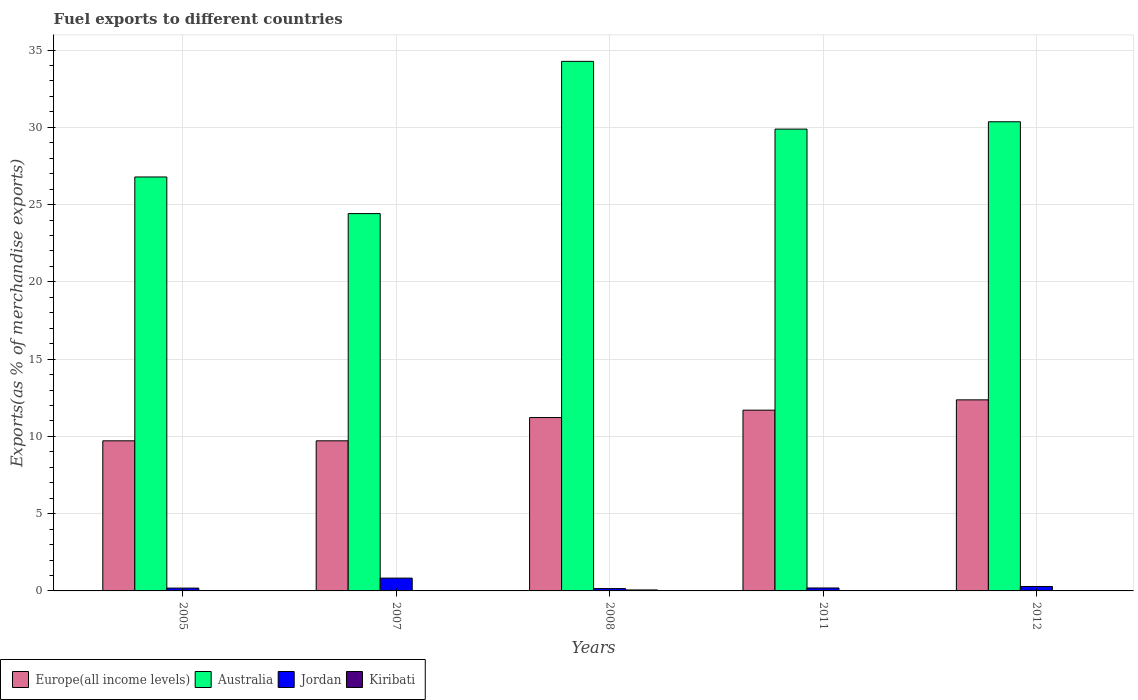How many different coloured bars are there?
Keep it short and to the point. 4. How many groups of bars are there?
Ensure brevity in your answer.  5. Are the number of bars per tick equal to the number of legend labels?
Provide a short and direct response. Yes. How many bars are there on the 2nd tick from the left?
Offer a terse response. 4. In how many cases, is the number of bars for a given year not equal to the number of legend labels?
Provide a short and direct response. 0. What is the percentage of exports to different countries in Europe(all income levels) in 2005?
Your answer should be compact. 9.71. Across all years, what is the maximum percentage of exports to different countries in Australia?
Offer a very short reply. 34.27. Across all years, what is the minimum percentage of exports to different countries in Australia?
Your answer should be very brief. 24.42. In which year was the percentage of exports to different countries in Australia maximum?
Your response must be concise. 2008. What is the total percentage of exports to different countries in Europe(all income levels) in the graph?
Ensure brevity in your answer.  54.7. What is the difference between the percentage of exports to different countries in Europe(all income levels) in 2005 and that in 2012?
Make the answer very short. -2.65. What is the difference between the percentage of exports to different countries in Australia in 2005 and the percentage of exports to different countries in Europe(all income levels) in 2012?
Your response must be concise. 14.42. What is the average percentage of exports to different countries in Kiribati per year?
Offer a terse response. 0.02. In the year 2007, what is the difference between the percentage of exports to different countries in Australia and percentage of exports to different countries in Kiribati?
Offer a very short reply. 24.42. What is the ratio of the percentage of exports to different countries in Europe(all income levels) in 2005 to that in 2008?
Offer a terse response. 0.87. Is the difference between the percentage of exports to different countries in Australia in 2005 and 2011 greater than the difference between the percentage of exports to different countries in Kiribati in 2005 and 2011?
Make the answer very short. No. What is the difference between the highest and the second highest percentage of exports to different countries in Kiribati?
Offer a very short reply. 0.05. What is the difference between the highest and the lowest percentage of exports to different countries in Australia?
Offer a terse response. 9.85. In how many years, is the percentage of exports to different countries in Australia greater than the average percentage of exports to different countries in Australia taken over all years?
Ensure brevity in your answer.  3. Is it the case that in every year, the sum of the percentage of exports to different countries in Jordan and percentage of exports to different countries in Europe(all income levels) is greater than the sum of percentage of exports to different countries in Kiribati and percentage of exports to different countries in Australia?
Offer a terse response. Yes. What does the 1st bar from the right in 2012 represents?
Provide a succinct answer. Kiribati. Is it the case that in every year, the sum of the percentage of exports to different countries in Europe(all income levels) and percentage of exports to different countries in Australia is greater than the percentage of exports to different countries in Jordan?
Keep it short and to the point. Yes. How many bars are there?
Offer a very short reply. 20. Are all the bars in the graph horizontal?
Make the answer very short. No. How many years are there in the graph?
Give a very brief answer. 5. What is the difference between two consecutive major ticks on the Y-axis?
Make the answer very short. 5. Are the values on the major ticks of Y-axis written in scientific E-notation?
Offer a very short reply. No. Does the graph contain any zero values?
Offer a very short reply. No. Does the graph contain grids?
Provide a succinct answer. Yes. How are the legend labels stacked?
Your answer should be compact. Horizontal. What is the title of the graph?
Ensure brevity in your answer.  Fuel exports to different countries. What is the label or title of the Y-axis?
Keep it short and to the point. Exports(as % of merchandise exports). What is the Exports(as % of merchandise exports) in Europe(all income levels) in 2005?
Your answer should be compact. 9.71. What is the Exports(as % of merchandise exports) of Australia in 2005?
Ensure brevity in your answer.  26.79. What is the Exports(as % of merchandise exports) of Jordan in 2005?
Provide a succinct answer. 0.18. What is the Exports(as % of merchandise exports) in Kiribati in 2005?
Provide a short and direct response. 0.02. What is the Exports(as % of merchandise exports) of Europe(all income levels) in 2007?
Make the answer very short. 9.71. What is the Exports(as % of merchandise exports) of Australia in 2007?
Provide a succinct answer. 24.42. What is the Exports(as % of merchandise exports) in Jordan in 2007?
Keep it short and to the point. 0.83. What is the Exports(as % of merchandise exports) in Kiribati in 2007?
Provide a short and direct response. 0. What is the Exports(as % of merchandise exports) in Europe(all income levels) in 2008?
Your response must be concise. 11.22. What is the Exports(as % of merchandise exports) of Australia in 2008?
Your response must be concise. 34.27. What is the Exports(as % of merchandise exports) of Jordan in 2008?
Provide a short and direct response. 0.15. What is the Exports(as % of merchandise exports) in Kiribati in 2008?
Keep it short and to the point. 0.06. What is the Exports(as % of merchandise exports) in Europe(all income levels) in 2011?
Offer a very short reply. 11.7. What is the Exports(as % of merchandise exports) of Australia in 2011?
Your answer should be compact. 29.88. What is the Exports(as % of merchandise exports) of Jordan in 2011?
Make the answer very short. 0.19. What is the Exports(as % of merchandise exports) of Kiribati in 2011?
Offer a terse response. 0. What is the Exports(as % of merchandise exports) in Europe(all income levels) in 2012?
Provide a succinct answer. 12.36. What is the Exports(as % of merchandise exports) of Australia in 2012?
Ensure brevity in your answer.  30.36. What is the Exports(as % of merchandise exports) in Jordan in 2012?
Make the answer very short. 0.29. What is the Exports(as % of merchandise exports) in Kiribati in 2012?
Ensure brevity in your answer.  0. Across all years, what is the maximum Exports(as % of merchandise exports) in Europe(all income levels)?
Ensure brevity in your answer.  12.36. Across all years, what is the maximum Exports(as % of merchandise exports) of Australia?
Your response must be concise. 34.27. Across all years, what is the maximum Exports(as % of merchandise exports) in Jordan?
Provide a short and direct response. 0.83. Across all years, what is the maximum Exports(as % of merchandise exports) of Kiribati?
Your response must be concise. 0.06. Across all years, what is the minimum Exports(as % of merchandise exports) in Europe(all income levels)?
Give a very brief answer. 9.71. Across all years, what is the minimum Exports(as % of merchandise exports) in Australia?
Offer a very short reply. 24.42. Across all years, what is the minimum Exports(as % of merchandise exports) of Jordan?
Make the answer very short. 0.15. Across all years, what is the minimum Exports(as % of merchandise exports) in Kiribati?
Offer a terse response. 0. What is the total Exports(as % of merchandise exports) of Europe(all income levels) in the graph?
Ensure brevity in your answer.  54.7. What is the total Exports(as % of merchandise exports) in Australia in the graph?
Give a very brief answer. 145.71. What is the total Exports(as % of merchandise exports) of Jordan in the graph?
Your answer should be compact. 1.64. What is the total Exports(as % of merchandise exports) of Kiribati in the graph?
Provide a short and direct response. 0.08. What is the difference between the Exports(as % of merchandise exports) of Europe(all income levels) in 2005 and that in 2007?
Your answer should be very brief. -0. What is the difference between the Exports(as % of merchandise exports) in Australia in 2005 and that in 2007?
Make the answer very short. 2.37. What is the difference between the Exports(as % of merchandise exports) in Jordan in 2005 and that in 2007?
Your answer should be very brief. -0.65. What is the difference between the Exports(as % of merchandise exports) in Kiribati in 2005 and that in 2007?
Your answer should be very brief. 0.02. What is the difference between the Exports(as % of merchandise exports) of Europe(all income levels) in 2005 and that in 2008?
Offer a terse response. -1.51. What is the difference between the Exports(as % of merchandise exports) in Australia in 2005 and that in 2008?
Give a very brief answer. -7.48. What is the difference between the Exports(as % of merchandise exports) in Jordan in 2005 and that in 2008?
Your response must be concise. 0.03. What is the difference between the Exports(as % of merchandise exports) of Kiribati in 2005 and that in 2008?
Give a very brief answer. -0.05. What is the difference between the Exports(as % of merchandise exports) of Europe(all income levels) in 2005 and that in 2011?
Your answer should be very brief. -1.98. What is the difference between the Exports(as % of merchandise exports) of Australia in 2005 and that in 2011?
Keep it short and to the point. -3.1. What is the difference between the Exports(as % of merchandise exports) of Jordan in 2005 and that in 2011?
Give a very brief answer. -0.01. What is the difference between the Exports(as % of merchandise exports) in Kiribati in 2005 and that in 2011?
Ensure brevity in your answer.  0.02. What is the difference between the Exports(as % of merchandise exports) of Europe(all income levels) in 2005 and that in 2012?
Provide a short and direct response. -2.65. What is the difference between the Exports(as % of merchandise exports) of Australia in 2005 and that in 2012?
Provide a succinct answer. -3.57. What is the difference between the Exports(as % of merchandise exports) in Jordan in 2005 and that in 2012?
Offer a very short reply. -0.11. What is the difference between the Exports(as % of merchandise exports) in Kiribati in 2005 and that in 2012?
Give a very brief answer. 0.02. What is the difference between the Exports(as % of merchandise exports) of Europe(all income levels) in 2007 and that in 2008?
Give a very brief answer. -1.51. What is the difference between the Exports(as % of merchandise exports) in Australia in 2007 and that in 2008?
Offer a very short reply. -9.85. What is the difference between the Exports(as % of merchandise exports) in Jordan in 2007 and that in 2008?
Your response must be concise. 0.68. What is the difference between the Exports(as % of merchandise exports) in Kiribati in 2007 and that in 2008?
Ensure brevity in your answer.  -0.06. What is the difference between the Exports(as % of merchandise exports) in Europe(all income levels) in 2007 and that in 2011?
Give a very brief answer. -1.98. What is the difference between the Exports(as % of merchandise exports) of Australia in 2007 and that in 2011?
Ensure brevity in your answer.  -5.47. What is the difference between the Exports(as % of merchandise exports) in Jordan in 2007 and that in 2011?
Make the answer very short. 0.64. What is the difference between the Exports(as % of merchandise exports) in Kiribati in 2007 and that in 2011?
Offer a very short reply. 0. What is the difference between the Exports(as % of merchandise exports) of Europe(all income levels) in 2007 and that in 2012?
Provide a succinct answer. -2.65. What is the difference between the Exports(as % of merchandise exports) in Australia in 2007 and that in 2012?
Give a very brief answer. -5.94. What is the difference between the Exports(as % of merchandise exports) in Jordan in 2007 and that in 2012?
Your answer should be compact. 0.54. What is the difference between the Exports(as % of merchandise exports) in Europe(all income levels) in 2008 and that in 2011?
Your answer should be compact. -0.48. What is the difference between the Exports(as % of merchandise exports) in Australia in 2008 and that in 2011?
Offer a terse response. 4.38. What is the difference between the Exports(as % of merchandise exports) in Jordan in 2008 and that in 2011?
Provide a succinct answer. -0.04. What is the difference between the Exports(as % of merchandise exports) of Kiribati in 2008 and that in 2011?
Your answer should be very brief. 0.06. What is the difference between the Exports(as % of merchandise exports) in Europe(all income levels) in 2008 and that in 2012?
Give a very brief answer. -1.15. What is the difference between the Exports(as % of merchandise exports) of Australia in 2008 and that in 2012?
Give a very brief answer. 3.91. What is the difference between the Exports(as % of merchandise exports) in Jordan in 2008 and that in 2012?
Offer a terse response. -0.14. What is the difference between the Exports(as % of merchandise exports) of Kiribati in 2008 and that in 2012?
Ensure brevity in your answer.  0.06. What is the difference between the Exports(as % of merchandise exports) in Europe(all income levels) in 2011 and that in 2012?
Provide a short and direct response. -0.67. What is the difference between the Exports(as % of merchandise exports) in Australia in 2011 and that in 2012?
Keep it short and to the point. -0.47. What is the difference between the Exports(as % of merchandise exports) of Jordan in 2011 and that in 2012?
Keep it short and to the point. -0.1. What is the difference between the Exports(as % of merchandise exports) in Kiribati in 2011 and that in 2012?
Provide a succinct answer. -0. What is the difference between the Exports(as % of merchandise exports) in Europe(all income levels) in 2005 and the Exports(as % of merchandise exports) in Australia in 2007?
Offer a terse response. -14.7. What is the difference between the Exports(as % of merchandise exports) of Europe(all income levels) in 2005 and the Exports(as % of merchandise exports) of Jordan in 2007?
Ensure brevity in your answer.  8.88. What is the difference between the Exports(as % of merchandise exports) of Europe(all income levels) in 2005 and the Exports(as % of merchandise exports) of Kiribati in 2007?
Ensure brevity in your answer.  9.71. What is the difference between the Exports(as % of merchandise exports) in Australia in 2005 and the Exports(as % of merchandise exports) in Jordan in 2007?
Offer a very short reply. 25.96. What is the difference between the Exports(as % of merchandise exports) in Australia in 2005 and the Exports(as % of merchandise exports) in Kiribati in 2007?
Provide a short and direct response. 26.79. What is the difference between the Exports(as % of merchandise exports) in Jordan in 2005 and the Exports(as % of merchandise exports) in Kiribati in 2007?
Keep it short and to the point. 0.18. What is the difference between the Exports(as % of merchandise exports) of Europe(all income levels) in 2005 and the Exports(as % of merchandise exports) of Australia in 2008?
Give a very brief answer. -24.55. What is the difference between the Exports(as % of merchandise exports) of Europe(all income levels) in 2005 and the Exports(as % of merchandise exports) of Jordan in 2008?
Provide a short and direct response. 9.56. What is the difference between the Exports(as % of merchandise exports) in Europe(all income levels) in 2005 and the Exports(as % of merchandise exports) in Kiribati in 2008?
Give a very brief answer. 9.65. What is the difference between the Exports(as % of merchandise exports) of Australia in 2005 and the Exports(as % of merchandise exports) of Jordan in 2008?
Ensure brevity in your answer.  26.63. What is the difference between the Exports(as % of merchandise exports) in Australia in 2005 and the Exports(as % of merchandise exports) in Kiribati in 2008?
Make the answer very short. 26.72. What is the difference between the Exports(as % of merchandise exports) in Jordan in 2005 and the Exports(as % of merchandise exports) in Kiribati in 2008?
Offer a terse response. 0.12. What is the difference between the Exports(as % of merchandise exports) of Europe(all income levels) in 2005 and the Exports(as % of merchandise exports) of Australia in 2011?
Provide a succinct answer. -20.17. What is the difference between the Exports(as % of merchandise exports) of Europe(all income levels) in 2005 and the Exports(as % of merchandise exports) of Jordan in 2011?
Provide a short and direct response. 9.52. What is the difference between the Exports(as % of merchandise exports) in Europe(all income levels) in 2005 and the Exports(as % of merchandise exports) in Kiribati in 2011?
Provide a short and direct response. 9.71. What is the difference between the Exports(as % of merchandise exports) in Australia in 2005 and the Exports(as % of merchandise exports) in Jordan in 2011?
Your answer should be very brief. 26.6. What is the difference between the Exports(as % of merchandise exports) in Australia in 2005 and the Exports(as % of merchandise exports) in Kiribati in 2011?
Provide a succinct answer. 26.79. What is the difference between the Exports(as % of merchandise exports) of Jordan in 2005 and the Exports(as % of merchandise exports) of Kiribati in 2011?
Offer a very short reply. 0.18. What is the difference between the Exports(as % of merchandise exports) of Europe(all income levels) in 2005 and the Exports(as % of merchandise exports) of Australia in 2012?
Offer a very short reply. -20.64. What is the difference between the Exports(as % of merchandise exports) of Europe(all income levels) in 2005 and the Exports(as % of merchandise exports) of Jordan in 2012?
Your answer should be very brief. 9.42. What is the difference between the Exports(as % of merchandise exports) of Europe(all income levels) in 2005 and the Exports(as % of merchandise exports) of Kiribati in 2012?
Provide a short and direct response. 9.71. What is the difference between the Exports(as % of merchandise exports) of Australia in 2005 and the Exports(as % of merchandise exports) of Jordan in 2012?
Your response must be concise. 26.5. What is the difference between the Exports(as % of merchandise exports) in Australia in 2005 and the Exports(as % of merchandise exports) in Kiribati in 2012?
Your answer should be very brief. 26.79. What is the difference between the Exports(as % of merchandise exports) in Jordan in 2005 and the Exports(as % of merchandise exports) in Kiribati in 2012?
Your answer should be very brief. 0.18. What is the difference between the Exports(as % of merchandise exports) in Europe(all income levels) in 2007 and the Exports(as % of merchandise exports) in Australia in 2008?
Provide a short and direct response. -24.55. What is the difference between the Exports(as % of merchandise exports) in Europe(all income levels) in 2007 and the Exports(as % of merchandise exports) in Jordan in 2008?
Provide a succinct answer. 9.56. What is the difference between the Exports(as % of merchandise exports) of Europe(all income levels) in 2007 and the Exports(as % of merchandise exports) of Kiribati in 2008?
Your answer should be compact. 9.65. What is the difference between the Exports(as % of merchandise exports) of Australia in 2007 and the Exports(as % of merchandise exports) of Jordan in 2008?
Make the answer very short. 24.27. What is the difference between the Exports(as % of merchandise exports) of Australia in 2007 and the Exports(as % of merchandise exports) of Kiribati in 2008?
Provide a short and direct response. 24.35. What is the difference between the Exports(as % of merchandise exports) in Jordan in 2007 and the Exports(as % of merchandise exports) in Kiribati in 2008?
Make the answer very short. 0.77. What is the difference between the Exports(as % of merchandise exports) in Europe(all income levels) in 2007 and the Exports(as % of merchandise exports) in Australia in 2011?
Your answer should be very brief. -20.17. What is the difference between the Exports(as % of merchandise exports) of Europe(all income levels) in 2007 and the Exports(as % of merchandise exports) of Jordan in 2011?
Provide a short and direct response. 9.52. What is the difference between the Exports(as % of merchandise exports) in Europe(all income levels) in 2007 and the Exports(as % of merchandise exports) in Kiribati in 2011?
Your response must be concise. 9.71. What is the difference between the Exports(as % of merchandise exports) in Australia in 2007 and the Exports(as % of merchandise exports) in Jordan in 2011?
Ensure brevity in your answer.  24.23. What is the difference between the Exports(as % of merchandise exports) of Australia in 2007 and the Exports(as % of merchandise exports) of Kiribati in 2011?
Provide a short and direct response. 24.42. What is the difference between the Exports(as % of merchandise exports) of Jordan in 2007 and the Exports(as % of merchandise exports) of Kiribati in 2011?
Your answer should be very brief. 0.83. What is the difference between the Exports(as % of merchandise exports) in Europe(all income levels) in 2007 and the Exports(as % of merchandise exports) in Australia in 2012?
Your answer should be compact. -20.64. What is the difference between the Exports(as % of merchandise exports) of Europe(all income levels) in 2007 and the Exports(as % of merchandise exports) of Jordan in 2012?
Offer a very short reply. 9.42. What is the difference between the Exports(as % of merchandise exports) in Europe(all income levels) in 2007 and the Exports(as % of merchandise exports) in Kiribati in 2012?
Give a very brief answer. 9.71. What is the difference between the Exports(as % of merchandise exports) in Australia in 2007 and the Exports(as % of merchandise exports) in Jordan in 2012?
Offer a very short reply. 24.13. What is the difference between the Exports(as % of merchandise exports) of Australia in 2007 and the Exports(as % of merchandise exports) of Kiribati in 2012?
Your response must be concise. 24.42. What is the difference between the Exports(as % of merchandise exports) in Jordan in 2007 and the Exports(as % of merchandise exports) in Kiribati in 2012?
Give a very brief answer. 0.83. What is the difference between the Exports(as % of merchandise exports) of Europe(all income levels) in 2008 and the Exports(as % of merchandise exports) of Australia in 2011?
Keep it short and to the point. -18.66. What is the difference between the Exports(as % of merchandise exports) in Europe(all income levels) in 2008 and the Exports(as % of merchandise exports) in Jordan in 2011?
Your answer should be very brief. 11.03. What is the difference between the Exports(as % of merchandise exports) in Europe(all income levels) in 2008 and the Exports(as % of merchandise exports) in Kiribati in 2011?
Your answer should be compact. 11.22. What is the difference between the Exports(as % of merchandise exports) in Australia in 2008 and the Exports(as % of merchandise exports) in Jordan in 2011?
Ensure brevity in your answer.  34.08. What is the difference between the Exports(as % of merchandise exports) of Australia in 2008 and the Exports(as % of merchandise exports) of Kiribati in 2011?
Provide a short and direct response. 34.27. What is the difference between the Exports(as % of merchandise exports) of Jordan in 2008 and the Exports(as % of merchandise exports) of Kiribati in 2011?
Your answer should be compact. 0.15. What is the difference between the Exports(as % of merchandise exports) of Europe(all income levels) in 2008 and the Exports(as % of merchandise exports) of Australia in 2012?
Keep it short and to the point. -19.14. What is the difference between the Exports(as % of merchandise exports) in Europe(all income levels) in 2008 and the Exports(as % of merchandise exports) in Jordan in 2012?
Make the answer very short. 10.93. What is the difference between the Exports(as % of merchandise exports) in Europe(all income levels) in 2008 and the Exports(as % of merchandise exports) in Kiribati in 2012?
Ensure brevity in your answer.  11.22. What is the difference between the Exports(as % of merchandise exports) in Australia in 2008 and the Exports(as % of merchandise exports) in Jordan in 2012?
Offer a terse response. 33.98. What is the difference between the Exports(as % of merchandise exports) of Australia in 2008 and the Exports(as % of merchandise exports) of Kiribati in 2012?
Your response must be concise. 34.27. What is the difference between the Exports(as % of merchandise exports) of Jordan in 2008 and the Exports(as % of merchandise exports) of Kiribati in 2012?
Provide a short and direct response. 0.15. What is the difference between the Exports(as % of merchandise exports) of Europe(all income levels) in 2011 and the Exports(as % of merchandise exports) of Australia in 2012?
Your answer should be very brief. -18.66. What is the difference between the Exports(as % of merchandise exports) of Europe(all income levels) in 2011 and the Exports(as % of merchandise exports) of Jordan in 2012?
Give a very brief answer. 11.41. What is the difference between the Exports(as % of merchandise exports) of Europe(all income levels) in 2011 and the Exports(as % of merchandise exports) of Kiribati in 2012?
Offer a terse response. 11.7. What is the difference between the Exports(as % of merchandise exports) of Australia in 2011 and the Exports(as % of merchandise exports) of Jordan in 2012?
Offer a very short reply. 29.6. What is the difference between the Exports(as % of merchandise exports) of Australia in 2011 and the Exports(as % of merchandise exports) of Kiribati in 2012?
Your answer should be very brief. 29.88. What is the difference between the Exports(as % of merchandise exports) of Jordan in 2011 and the Exports(as % of merchandise exports) of Kiribati in 2012?
Keep it short and to the point. 0.19. What is the average Exports(as % of merchandise exports) of Europe(all income levels) per year?
Your answer should be compact. 10.94. What is the average Exports(as % of merchandise exports) in Australia per year?
Give a very brief answer. 29.14. What is the average Exports(as % of merchandise exports) in Jordan per year?
Ensure brevity in your answer.  0.33. What is the average Exports(as % of merchandise exports) of Kiribati per year?
Your answer should be very brief. 0.02. In the year 2005, what is the difference between the Exports(as % of merchandise exports) in Europe(all income levels) and Exports(as % of merchandise exports) in Australia?
Provide a succinct answer. -17.07. In the year 2005, what is the difference between the Exports(as % of merchandise exports) in Europe(all income levels) and Exports(as % of merchandise exports) in Jordan?
Make the answer very short. 9.53. In the year 2005, what is the difference between the Exports(as % of merchandise exports) of Europe(all income levels) and Exports(as % of merchandise exports) of Kiribati?
Provide a short and direct response. 9.7. In the year 2005, what is the difference between the Exports(as % of merchandise exports) in Australia and Exports(as % of merchandise exports) in Jordan?
Your answer should be very brief. 26.6. In the year 2005, what is the difference between the Exports(as % of merchandise exports) in Australia and Exports(as % of merchandise exports) in Kiribati?
Ensure brevity in your answer.  26.77. In the year 2005, what is the difference between the Exports(as % of merchandise exports) in Jordan and Exports(as % of merchandise exports) in Kiribati?
Keep it short and to the point. 0.17. In the year 2007, what is the difference between the Exports(as % of merchandise exports) of Europe(all income levels) and Exports(as % of merchandise exports) of Australia?
Keep it short and to the point. -14.7. In the year 2007, what is the difference between the Exports(as % of merchandise exports) in Europe(all income levels) and Exports(as % of merchandise exports) in Jordan?
Make the answer very short. 8.88. In the year 2007, what is the difference between the Exports(as % of merchandise exports) in Europe(all income levels) and Exports(as % of merchandise exports) in Kiribati?
Make the answer very short. 9.71. In the year 2007, what is the difference between the Exports(as % of merchandise exports) of Australia and Exports(as % of merchandise exports) of Jordan?
Make the answer very short. 23.59. In the year 2007, what is the difference between the Exports(as % of merchandise exports) in Australia and Exports(as % of merchandise exports) in Kiribati?
Your response must be concise. 24.42. In the year 2007, what is the difference between the Exports(as % of merchandise exports) of Jordan and Exports(as % of merchandise exports) of Kiribati?
Keep it short and to the point. 0.83. In the year 2008, what is the difference between the Exports(as % of merchandise exports) in Europe(all income levels) and Exports(as % of merchandise exports) in Australia?
Provide a short and direct response. -23.05. In the year 2008, what is the difference between the Exports(as % of merchandise exports) of Europe(all income levels) and Exports(as % of merchandise exports) of Jordan?
Ensure brevity in your answer.  11.07. In the year 2008, what is the difference between the Exports(as % of merchandise exports) of Europe(all income levels) and Exports(as % of merchandise exports) of Kiribati?
Your response must be concise. 11.16. In the year 2008, what is the difference between the Exports(as % of merchandise exports) of Australia and Exports(as % of merchandise exports) of Jordan?
Your answer should be compact. 34.12. In the year 2008, what is the difference between the Exports(as % of merchandise exports) in Australia and Exports(as % of merchandise exports) in Kiribati?
Provide a succinct answer. 34.2. In the year 2008, what is the difference between the Exports(as % of merchandise exports) in Jordan and Exports(as % of merchandise exports) in Kiribati?
Give a very brief answer. 0.09. In the year 2011, what is the difference between the Exports(as % of merchandise exports) of Europe(all income levels) and Exports(as % of merchandise exports) of Australia?
Give a very brief answer. -18.19. In the year 2011, what is the difference between the Exports(as % of merchandise exports) in Europe(all income levels) and Exports(as % of merchandise exports) in Jordan?
Offer a terse response. 11.51. In the year 2011, what is the difference between the Exports(as % of merchandise exports) in Europe(all income levels) and Exports(as % of merchandise exports) in Kiribati?
Keep it short and to the point. 11.7. In the year 2011, what is the difference between the Exports(as % of merchandise exports) in Australia and Exports(as % of merchandise exports) in Jordan?
Your answer should be very brief. 29.69. In the year 2011, what is the difference between the Exports(as % of merchandise exports) of Australia and Exports(as % of merchandise exports) of Kiribati?
Make the answer very short. 29.88. In the year 2011, what is the difference between the Exports(as % of merchandise exports) in Jordan and Exports(as % of merchandise exports) in Kiribati?
Ensure brevity in your answer.  0.19. In the year 2012, what is the difference between the Exports(as % of merchandise exports) in Europe(all income levels) and Exports(as % of merchandise exports) in Australia?
Offer a very short reply. -17.99. In the year 2012, what is the difference between the Exports(as % of merchandise exports) of Europe(all income levels) and Exports(as % of merchandise exports) of Jordan?
Make the answer very short. 12.08. In the year 2012, what is the difference between the Exports(as % of merchandise exports) in Europe(all income levels) and Exports(as % of merchandise exports) in Kiribati?
Offer a very short reply. 12.36. In the year 2012, what is the difference between the Exports(as % of merchandise exports) in Australia and Exports(as % of merchandise exports) in Jordan?
Offer a very short reply. 30.07. In the year 2012, what is the difference between the Exports(as % of merchandise exports) of Australia and Exports(as % of merchandise exports) of Kiribati?
Provide a short and direct response. 30.36. In the year 2012, what is the difference between the Exports(as % of merchandise exports) of Jordan and Exports(as % of merchandise exports) of Kiribati?
Ensure brevity in your answer.  0.29. What is the ratio of the Exports(as % of merchandise exports) of Australia in 2005 to that in 2007?
Your answer should be very brief. 1.1. What is the ratio of the Exports(as % of merchandise exports) in Jordan in 2005 to that in 2007?
Ensure brevity in your answer.  0.22. What is the ratio of the Exports(as % of merchandise exports) of Kiribati in 2005 to that in 2007?
Your response must be concise. 69.38. What is the ratio of the Exports(as % of merchandise exports) of Europe(all income levels) in 2005 to that in 2008?
Your answer should be very brief. 0.87. What is the ratio of the Exports(as % of merchandise exports) of Australia in 2005 to that in 2008?
Offer a very short reply. 0.78. What is the ratio of the Exports(as % of merchandise exports) in Jordan in 2005 to that in 2008?
Your response must be concise. 1.21. What is the ratio of the Exports(as % of merchandise exports) in Kiribati in 2005 to that in 2008?
Offer a very short reply. 0.27. What is the ratio of the Exports(as % of merchandise exports) in Europe(all income levels) in 2005 to that in 2011?
Your response must be concise. 0.83. What is the ratio of the Exports(as % of merchandise exports) in Australia in 2005 to that in 2011?
Offer a very short reply. 0.9. What is the ratio of the Exports(as % of merchandise exports) in Jordan in 2005 to that in 2011?
Ensure brevity in your answer.  0.96. What is the ratio of the Exports(as % of merchandise exports) of Kiribati in 2005 to that in 2011?
Make the answer very short. 147.01. What is the ratio of the Exports(as % of merchandise exports) in Europe(all income levels) in 2005 to that in 2012?
Keep it short and to the point. 0.79. What is the ratio of the Exports(as % of merchandise exports) in Australia in 2005 to that in 2012?
Provide a short and direct response. 0.88. What is the ratio of the Exports(as % of merchandise exports) in Jordan in 2005 to that in 2012?
Offer a terse response. 0.63. What is the ratio of the Exports(as % of merchandise exports) of Kiribati in 2005 to that in 2012?
Provide a succinct answer. 99.44. What is the ratio of the Exports(as % of merchandise exports) in Europe(all income levels) in 2007 to that in 2008?
Offer a terse response. 0.87. What is the ratio of the Exports(as % of merchandise exports) in Australia in 2007 to that in 2008?
Your answer should be very brief. 0.71. What is the ratio of the Exports(as % of merchandise exports) in Jordan in 2007 to that in 2008?
Your response must be concise. 5.5. What is the ratio of the Exports(as % of merchandise exports) in Kiribati in 2007 to that in 2008?
Make the answer very short. 0. What is the ratio of the Exports(as % of merchandise exports) of Europe(all income levels) in 2007 to that in 2011?
Keep it short and to the point. 0.83. What is the ratio of the Exports(as % of merchandise exports) of Australia in 2007 to that in 2011?
Your response must be concise. 0.82. What is the ratio of the Exports(as % of merchandise exports) in Jordan in 2007 to that in 2011?
Ensure brevity in your answer.  4.35. What is the ratio of the Exports(as % of merchandise exports) of Kiribati in 2007 to that in 2011?
Your answer should be very brief. 2.12. What is the ratio of the Exports(as % of merchandise exports) in Europe(all income levels) in 2007 to that in 2012?
Your answer should be compact. 0.79. What is the ratio of the Exports(as % of merchandise exports) in Australia in 2007 to that in 2012?
Make the answer very short. 0.8. What is the ratio of the Exports(as % of merchandise exports) of Jordan in 2007 to that in 2012?
Your answer should be compact. 2.88. What is the ratio of the Exports(as % of merchandise exports) in Kiribati in 2007 to that in 2012?
Ensure brevity in your answer.  1.43. What is the ratio of the Exports(as % of merchandise exports) of Europe(all income levels) in 2008 to that in 2011?
Give a very brief answer. 0.96. What is the ratio of the Exports(as % of merchandise exports) in Australia in 2008 to that in 2011?
Your answer should be very brief. 1.15. What is the ratio of the Exports(as % of merchandise exports) in Jordan in 2008 to that in 2011?
Make the answer very short. 0.79. What is the ratio of the Exports(as % of merchandise exports) of Kiribati in 2008 to that in 2011?
Give a very brief answer. 540.83. What is the ratio of the Exports(as % of merchandise exports) of Europe(all income levels) in 2008 to that in 2012?
Provide a succinct answer. 0.91. What is the ratio of the Exports(as % of merchandise exports) of Australia in 2008 to that in 2012?
Your answer should be very brief. 1.13. What is the ratio of the Exports(as % of merchandise exports) in Jordan in 2008 to that in 2012?
Provide a succinct answer. 0.52. What is the ratio of the Exports(as % of merchandise exports) in Kiribati in 2008 to that in 2012?
Make the answer very short. 365.82. What is the ratio of the Exports(as % of merchandise exports) in Europe(all income levels) in 2011 to that in 2012?
Provide a succinct answer. 0.95. What is the ratio of the Exports(as % of merchandise exports) of Australia in 2011 to that in 2012?
Your answer should be compact. 0.98. What is the ratio of the Exports(as % of merchandise exports) of Jordan in 2011 to that in 2012?
Provide a succinct answer. 0.66. What is the ratio of the Exports(as % of merchandise exports) in Kiribati in 2011 to that in 2012?
Give a very brief answer. 0.68. What is the difference between the highest and the second highest Exports(as % of merchandise exports) in Europe(all income levels)?
Ensure brevity in your answer.  0.67. What is the difference between the highest and the second highest Exports(as % of merchandise exports) in Australia?
Provide a succinct answer. 3.91. What is the difference between the highest and the second highest Exports(as % of merchandise exports) of Jordan?
Give a very brief answer. 0.54. What is the difference between the highest and the second highest Exports(as % of merchandise exports) of Kiribati?
Keep it short and to the point. 0.05. What is the difference between the highest and the lowest Exports(as % of merchandise exports) in Europe(all income levels)?
Keep it short and to the point. 2.65. What is the difference between the highest and the lowest Exports(as % of merchandise exports) in Australia?
Provide a short and direct response. 9.85. What is the difference between the highest and the lowest Exports(as % of merchandise exports) in Jordan?
Provide a succinct answer. 0.68. What is the difference between the highest and the lowest Exports(as % of merchandise exports) of Kiribati?
Offer a terse response. 0.06. 